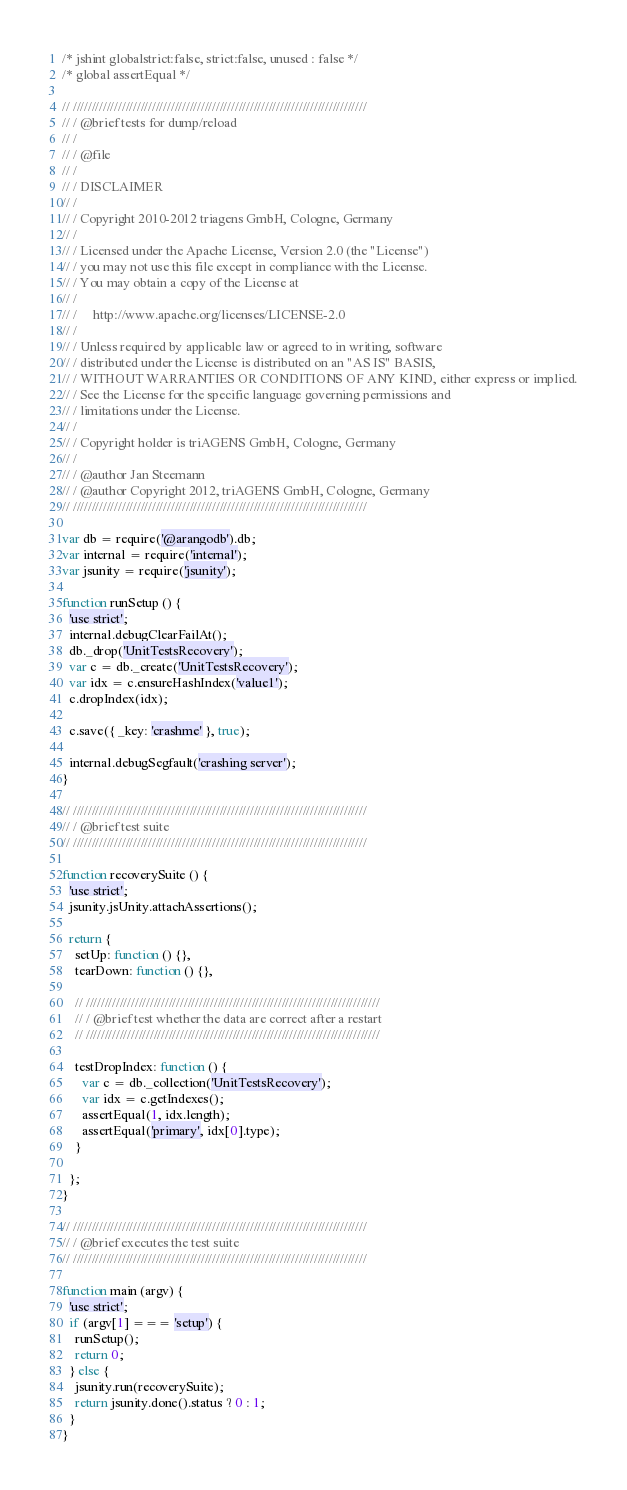<code> <loc_0><loc_0><loc_500><loc_500><_JavaScript_>/* jshint globalstrict:false, strict:false, unused : false */
/* global assertEqual */

// //////////////////////////////////////////////////////////////////////////////
// / @brief tests for dump/reload
// /
// / @file
// /
// / DISCLAIMER
// /
// / Copyright 2010-2012 triagens GmbH, Cologne, Germany
// /
// / Licensed under the Apache License, Version 2.0 (the "License")
// / you may not use this file except in compliance with the License.
// / You may obtain a copy of the License at
// /
// /     http://www.apache.org/licenses/LICENSE-2.0
// /
// / Unless required by applicable law or agreed to in writing, software
// / distributed under the License is distributed on an "AS IS" BASIS,
// / WITHOUT WARRANTIES OR CONDITIONS OF ANY KIND, either express or implied.
// / See the License for the specific language governing permissions and
// / limitations under the License.
// /
// / Copyright holder is triAGENS GmbH, Cologne, Germany
// /
// / @author Jan Steemann
// / @author Copyright 2012, triAGENS GmbH, Cologne, Germany
// //////////////////////////////////////////////////////////////////////////////

var db = require('@arangodb').db;
var internal = require('internal');
var jsunity = require('jsunity');

function runSetup () {
  'use strict';
  internal.debugClearFailAt();
  db._drop('UnitTestsRecovery');
  var c = db._create('UnitTestsRecovery');
  var idx = c.ensureHashIndex('value1');
  c.dropIndex(idx);

  c.save({ _key: 'crashme' }, true);

  internal.debugSegfault('crashing server');
}

// //////////////////////////////////////////////////////////////////////////////
// / @brief test suite
// //////////////////////////////////////////////////////////////////////////////

function recoverySuite () {
  'use strict';
  jsunity.jsUnity.attachAssertions();

  return {
    setUp: function () {},
    tearDown: function () {},

    // //////////////////////////////////////////////////////////////////////////////
    // / @brief test whether the data are correct after a restart
    // //////////////////////////////////////////////////////////////////////////////

    testDropIndex: function () {
      var c = db._collection('UnitTestsRecovery');
      var idx = c.getIndexes();
      assertEqual(1, idx.length);
      assertEqual('primary', idx[0].type);
    }

  };
}

// //////////////////////////////////////////////////////////////////////////////
// / @brief executes the test suite
// //////////////////////////////////////////////////////////////////////////////

function main (argv) {
  'use strict';
  if (argv[1] === 'setup') {
    runSetup();
    return 0;
  } else {
    jsunity.run(recoverySuite);
    return jsunity.done().status ? 0 : 1;
  }
}
</code> 